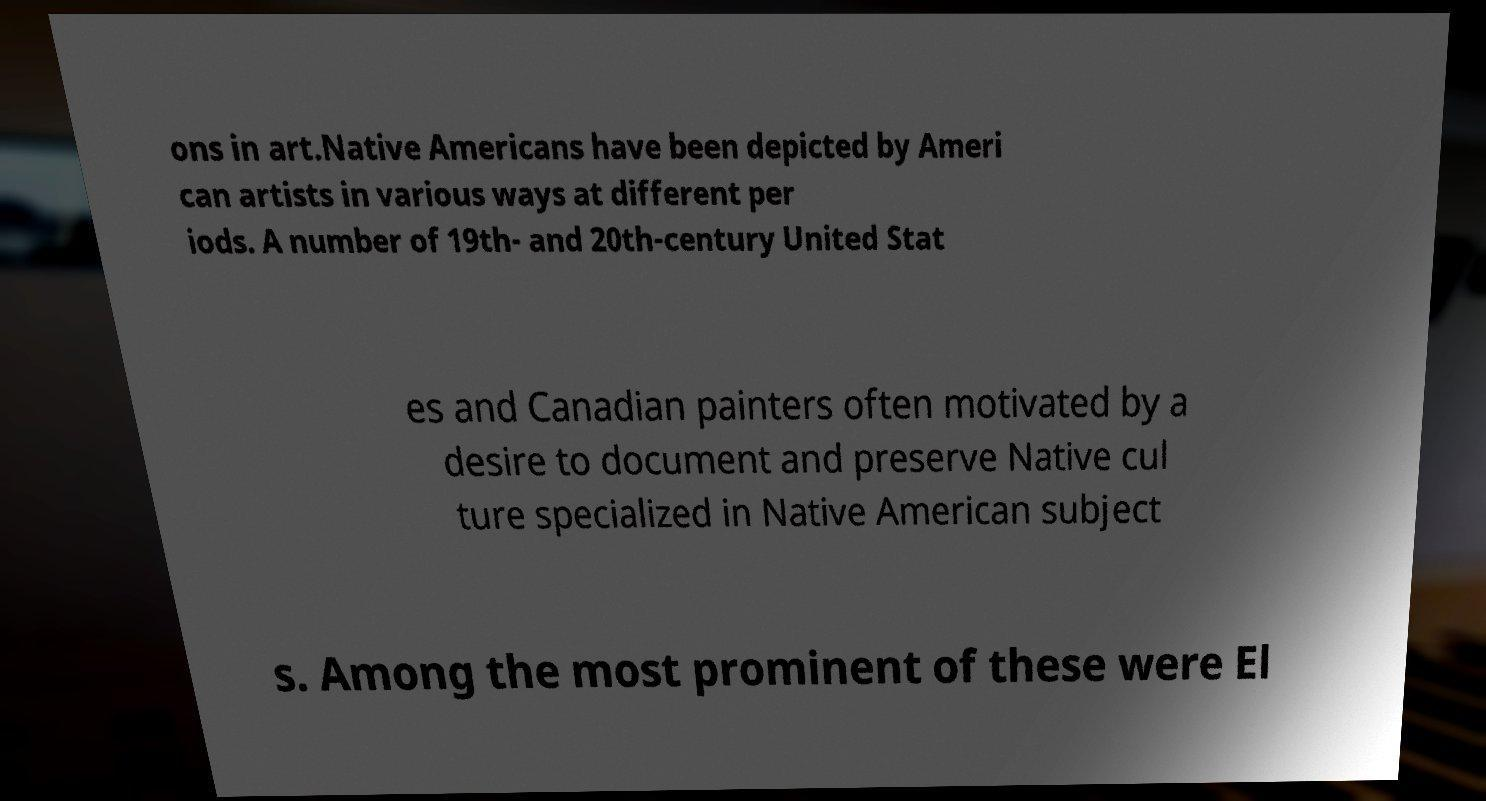What messages or text are displayed in this image? I need them in a readable, typed format. ons in art.Native Americans have been depicted by Ameri can artists in various ways at different per iods. A number of 19th- and 20th-century United Stat es and Canadian painters often motivated by a desire to document and preserve Native cul ture specialized in Native American subject s. Among the most prominent of these were El 